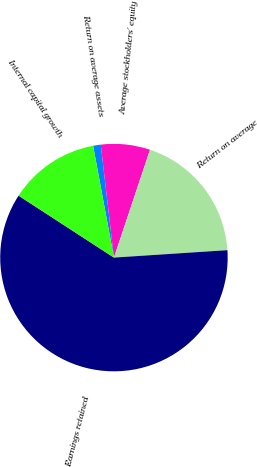Convert chart to OTSL. <chart><loc_0><loc_0><loc_500><loc_500><pie_chart><fcel>Return on average assets<fcel>Average stockholders' equity<fcel>Return on average<fcel>Earnings retained<fcel>Internal capital growth<nl><fcel>1.08%<fcel>6.99%<fcel>18.82%<fcel>60.21%<fcel>12.9%<nl></chart> 